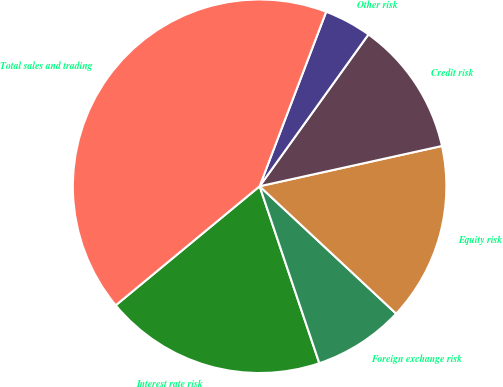Convert chart. <chart><loc_0><loc_0><loc_500><loc_500><pie_chart><fcel>Interest rate risk<fcel>Foreign exchange risk<fcel>Equity risk<fcel>Credit risk<fcel>Other risk<fcel>Total sales and trading<nl><fcel>19.18%<fcel>7.87%<fcel>15.41%<fcel>11.64%<fcel>4.1%<fcel>41.8%<nl></chart> 